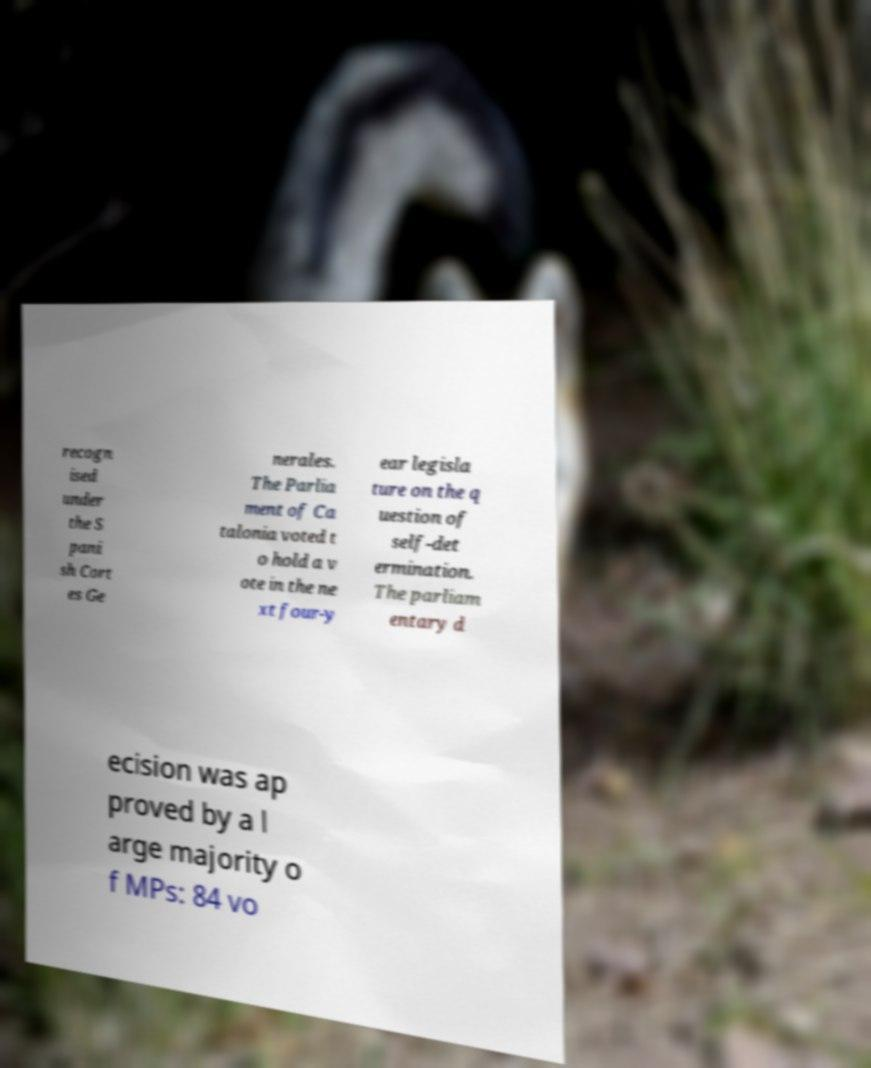For documentation purposes, I need the text within this image transcribed. Could you provide that? recogn ised under the S pani sh Cort es Ge nerales. The Parlia ment of Ca talonia voted t o hold a v ote in the ne xt four-y ear legisla ture on the q uestion of self-det ermination. The parliam entary d ecision was ap proved by a l arge majority o f MPs: 84 vo 